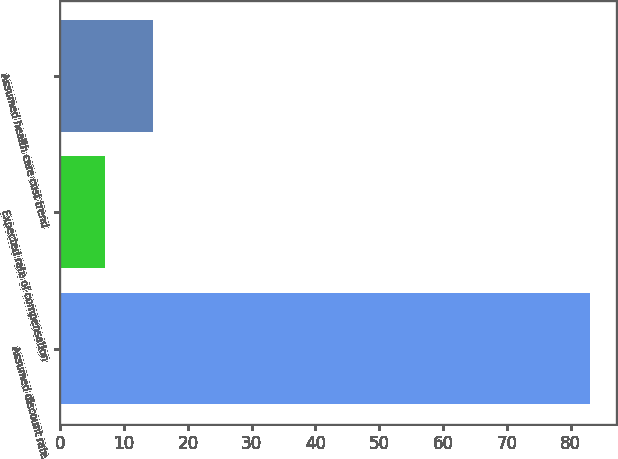Convert chart. <chart><loc_0><loc_0><loc_500><loc_500><bar_chart><fcel>Assumed discount rate<fcel>Expected rate of compensation<fcel>Assumed health care cost trend<nl><fcel>83<fcel>7<fcel>14.6<nl></chart> 